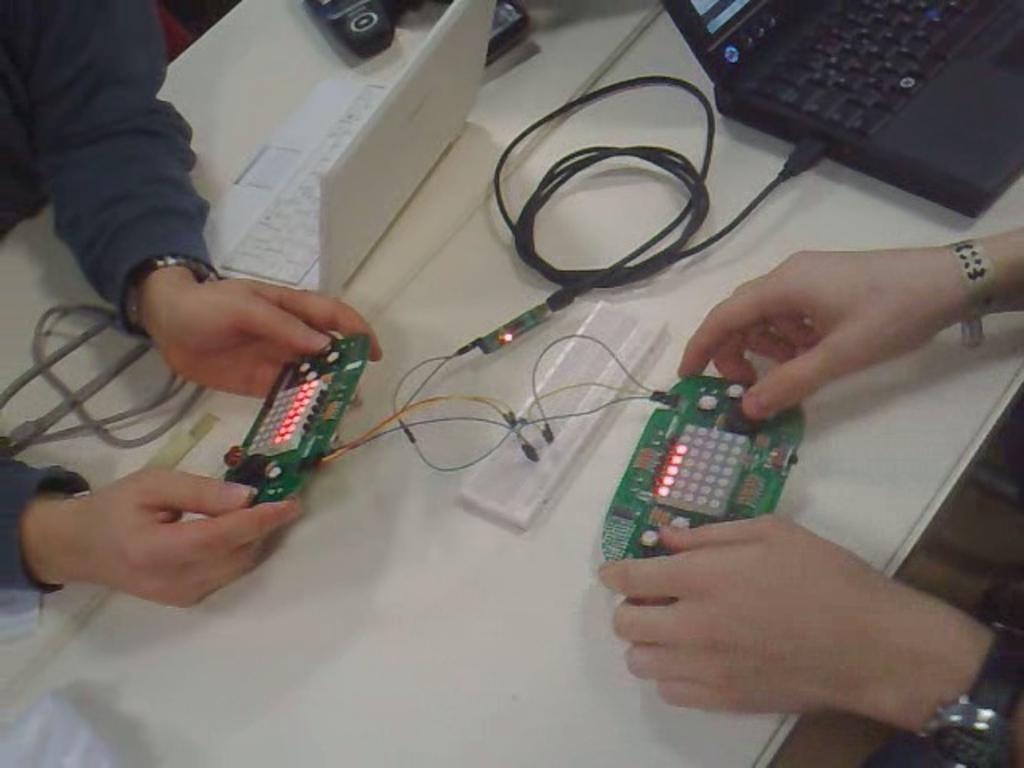In one or two sentences, can you explain what this image depicts? In this image, there is a table with laptops, cables and few other objects. On the left and right side of the image, I can see the hands of two people holding the objects. 